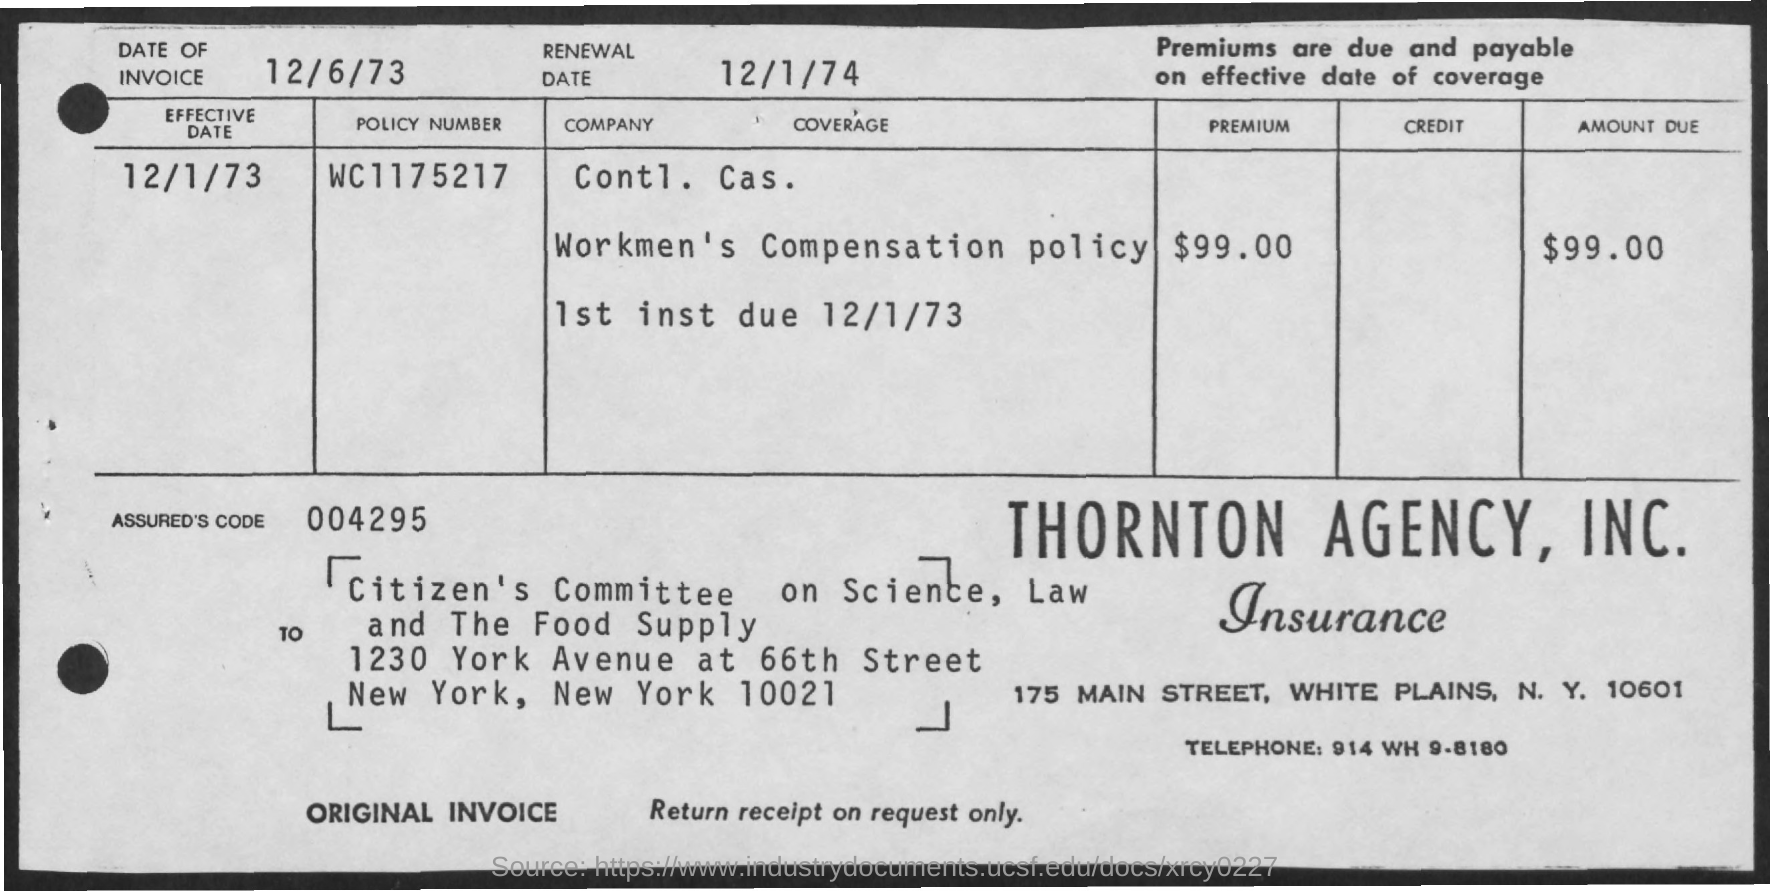Highlight a few significant elements in this photo. The premium is $99.00. The telephone is a device that allows for voice communication over a distance through the use of electronic signals. The Assured's code is 004295... The renewal date is December 1st, 1974. The amount due is $99.00. 